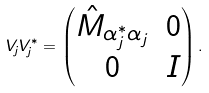Convert formula to latex. <formula><loc_0><loc_0><loc_500><loc_500>V _ { j } V _ { j } ^ { * } = \begin{pmatrix} \hat { M } _ { \alpha _ { j } ^ { * } \alpha _ { j } } & 0 \\ 0 & I \end{pmatrix} .</formula> 